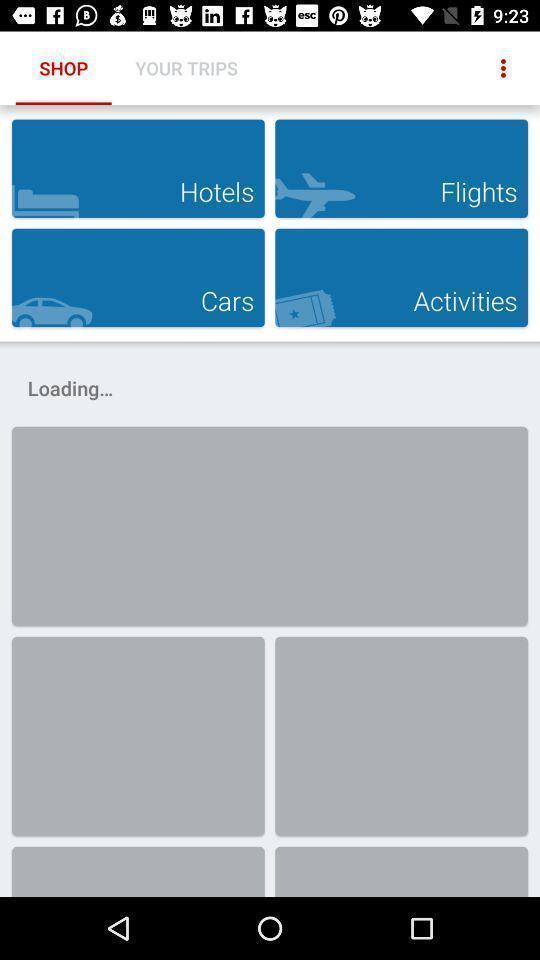Describe this image in words. Page displaying different options available in application to shop. 